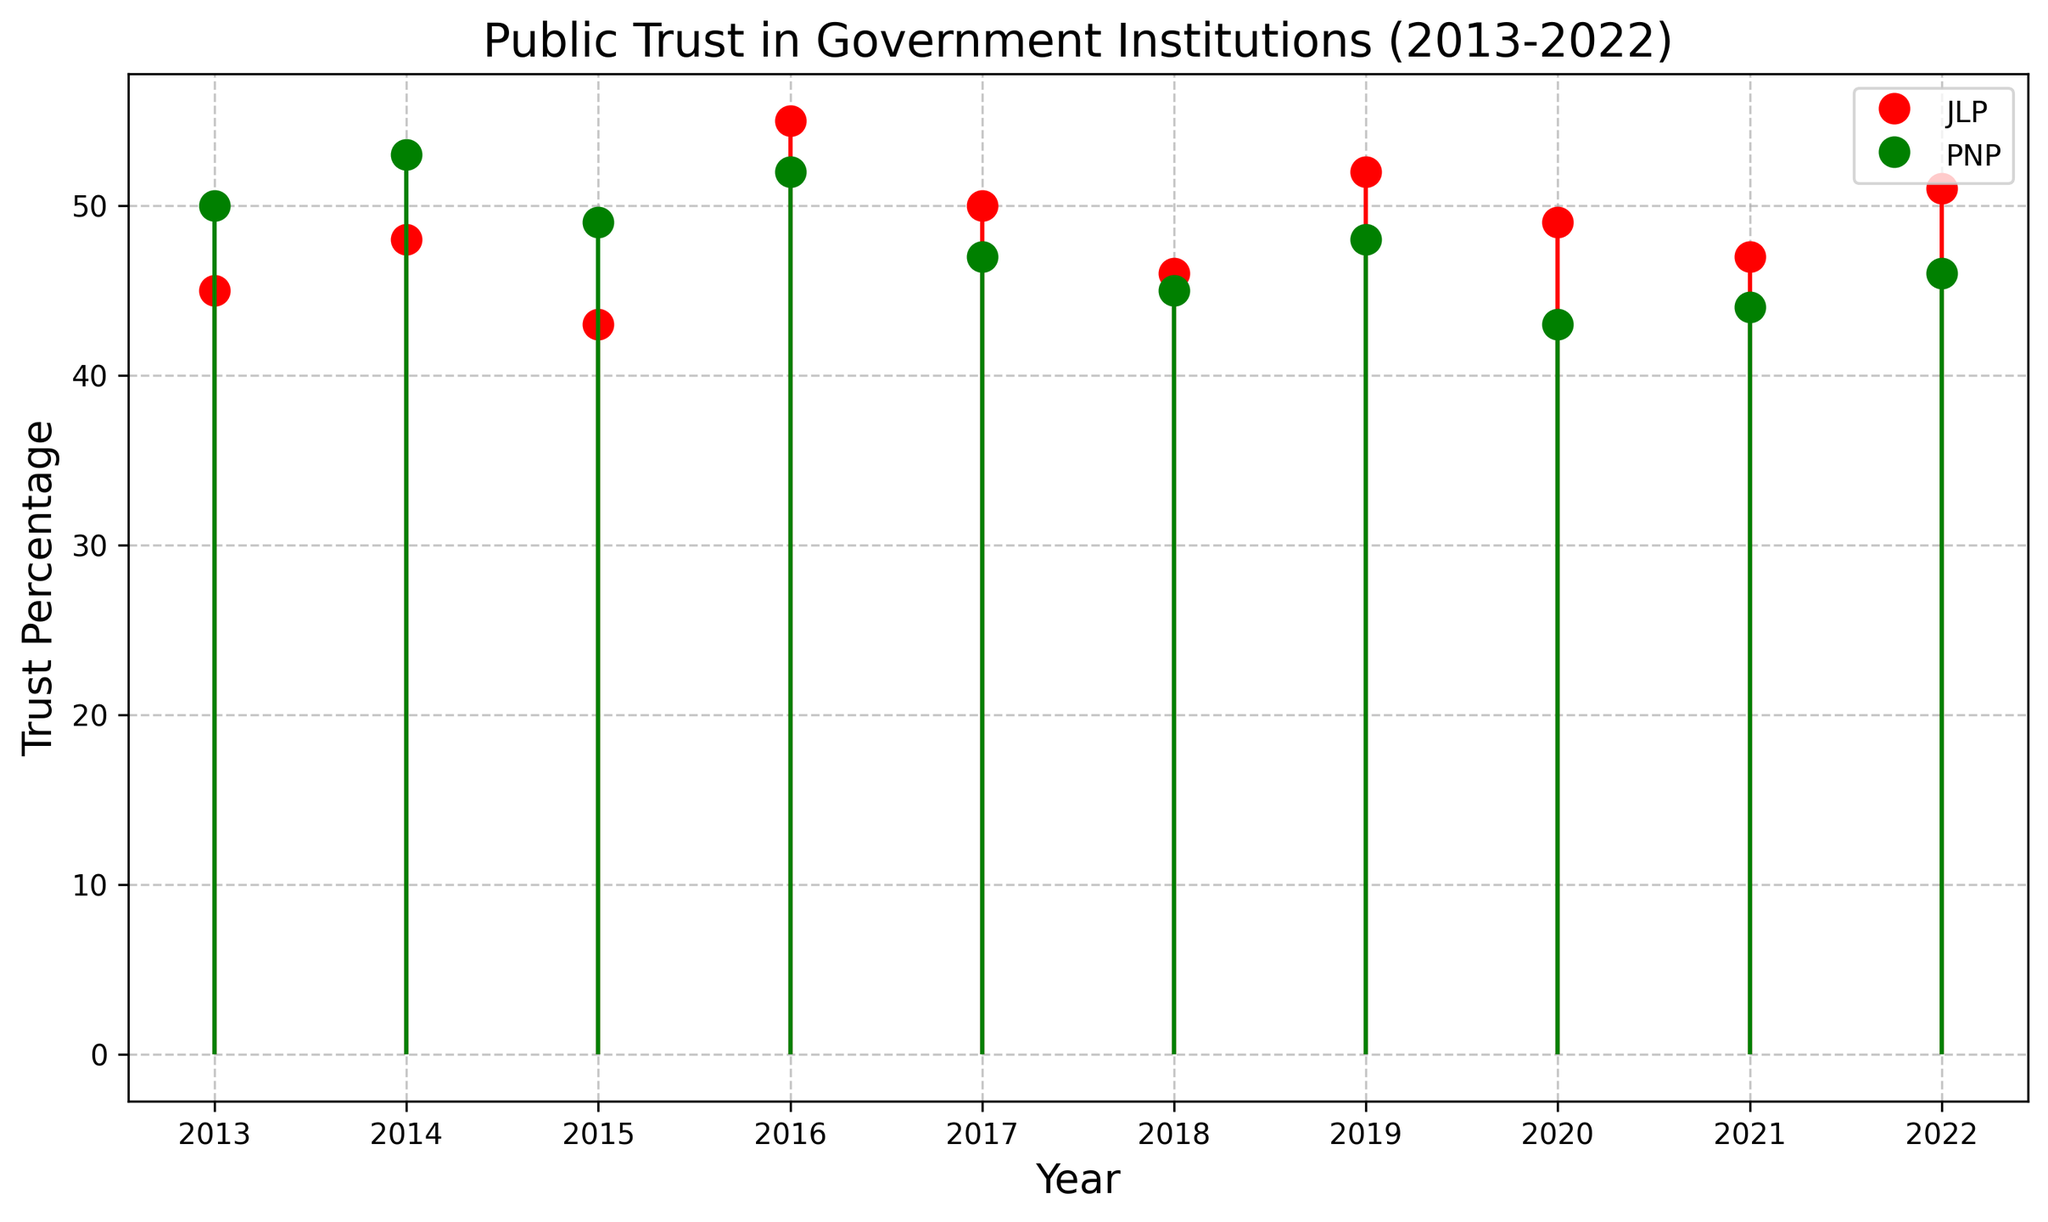What is the trend for trust in government institutions among JLP supporters from 2013 to 2022? The plot shows the trust percentages for JLP supporters each year from 2013 to 2022. By observing the stem plot, we can see the changes over the years. Trust peaked in 2016 at 55% and reached its lowest point in 2015 at 43%. Overall, the trend is slightly upwards despite some fluctuations.
Answer: Slightly upwards How do the trust levels in 2016 compare between JLP and PNP supporters? The plot shows the trust percentage for JLP in 2016 is 55% whereas for PNP it is 52%. By comparing these two percentages, we see that trust among JLP supporters is higher than among PNP supporters in 2016.
Answer: JLP higher What is the average trust percentage for PNP supporters over the decade? To find the average, sum all trust percentages for PNP supporters from 2013 to 2022 and divide by the number of years. (50 + 53 + 49 + 52 + 47 + 45 + 48 + 43 + 44 + 46) = 477, then 477 / 10 = 47.7%
Answer: 47.7% Which year saw the highest trust percentage among JLP supporters, and what was that percentage? According to the plot, the highest stem for JLP supporters is in the year 2016, at a trust percentage of 55%.
Answer: 2016, 55% In which year did PNP supporters experience the lowest trust in government institutions? By observing the stem plot, the lowest point for PNP supporters is in 2020, with a trust percentage of 43%.
Answer: 2020 What is the difference in trust percentage between JLP and PNP supporters in 2015? The plot shows 43% trust for JLP and 49% for PNP in 2015. The difference is calculated as 49% - 43% = 6%.
Answer: 6% How do trust percentages compare between JLP and PNP supporters in 2017? In the year 2017, JLP has a trust percentage of 50%, while PNP has 47%. Hence, JLP supporters have a higher trust percentage by 3%.
Answer: JLP higher by 3% What color is used to represent the trust levels of PNP supporters in the plot? The plot uses green for the trust levels of PNP supporters, indicated by the 'og' markers and green stem lines.
Answer: Green Which political affiliation shows a greater increase in trust from 2020 to 2022? The plot shows that JLP trust percentage increased from 49% in 2020 to 51% in 2022 (an increase of 2%), while PNP trust percentage increased from 43% in 2020 to 46% in 2022 (an increase of 3%). Hence, PNP shows a greater increase.
Answer: PNP What is the approximate median trust percentage for JLP supporters over the decade? To find the median, first arrange the trust percentages of JLP supporters in ascending order: 43, 45, 46, 47, 48, 49, 50, 51, 52, 55. The median is the average of the 5th and 6th values (48 and 49), so (48 + 49) / 2 = 48.5%.
Answer: 48.5% 